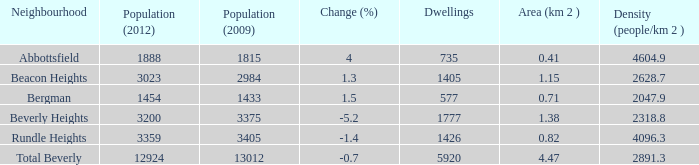What is the density of a zone that is 0.0. 